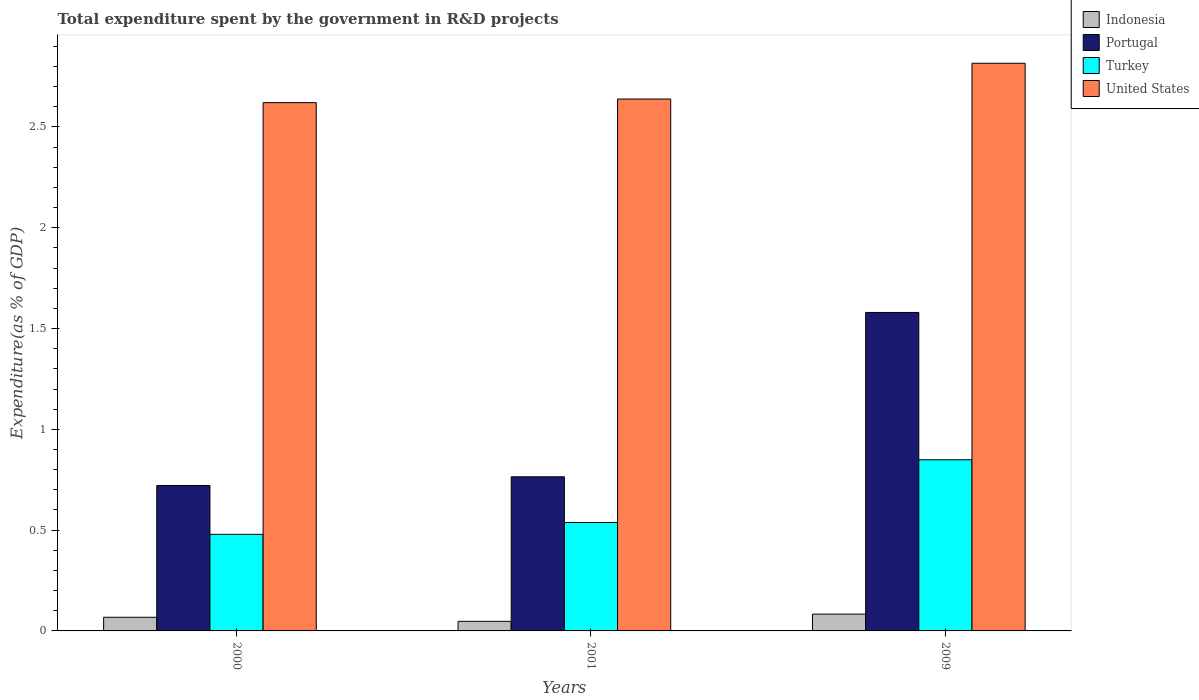How many different coloured bars are there?
Ensure brevity in your answer.  4. Are the number of bars per tick equal to the number of legend labels?
Your answer should be very brief. Yes. How many bars are there on the 2nd tick from the left?
Your answer should be compact. 4. How many bars are there on the 3rd tick from the right?
Your answer should be very brief. 4. What is the label of the 3rd group of bars from the left?
Keep it short and to the point. 2009. In how many cases, is the number of bars for a given year not equal to the number of legend labels?
Provide a short and direct response. 0. What is the total expenditure spent by the government in R&D projects in Turkey in 2000?
Provide a succinct answer. 0.48. Across all years, what is the maximum total expenditure spent by the government in R&D projects in United States?
Keep it short and to the point. 2.82. Across all years, what is the minimum total expenditure spent by the government in R&D projects in Indonesia?
Ensure brevity in your answer.  0.05. In which year was the total expenditure spent by the government in R&D projects in Indonesia maximum?
Offer a terse response. 2009. In which year was the total expenditure spent by the government in R&D projects in Portugal minimum?
Ensure brevity in your answer.  2000. What is the total total expenditure spent by the government in R&D projects in Turkey in the graph?
Give a very brief answer. 1.87. What is the difference between the total expenditure spent by the government in R&D projects in Indonesia in 2001 and that in 2009?
Offer a terse response. -0.04. What is the difference between the total expenditure spent by the government in R&D projects in Indonesia in 2000 and the total expenditure spent by the government in R&D projects in Portugal in 2009?
Your response must be concise. -1.51. What is the average total expenditure spent by the government in R&D projects in Indonesia per year?
Your response must be concise. 0.07. In the year 2009, what is the difference between the total expenditure spent by the government in R&D projects in Portugal and total expenditure spent by the government in R&D projects in Turkey?
Your answer should be compact. 0.73. In how many years, is the total expenditure spent by the government in R&D projects in Indonesia greater than 0.4 %?
Give a very brief answer. 0. What is the ratio of the total expenditure spent by the government in R&D projects in Turkey in 2000 to that in 2009?
Ensure brevity in your answer.  0.56. Is the total expenditure spent by the government in R&D projects in Indonesia in 2000 less than that in 2009?
Give a very brief answer. Yes. What is the difference between the highest and the second highest total expenditure spent by the government in R&D projects in United States?
Your answer should be very brief. 0.18. What is the difference between the highest and the lowest total expenditure spent by the government in R&D projects in United States?
Ensure brevity in your answer.  0.2. In how many years, is the total expenditure spent by the government in R&D projects in Indonesia greater than the average total expenditure spent by the government in R&D projects in Indonesia taken over all years?
Ensure brevity in your answer.  2. Is it the case that in every year, the sum of the total expenditure spent by the government in R&D projects in Indonesia and total expenditure spent by the government in R&D projects in Portugal is greater than the total expenditure spent by the government in R&D projects in Turkey?
Keep it short and to the point. Yes. Are all the bars in the graph horizontal?
Ensure brevity in your answer.  No. How many years are there in the graph?
Keep it short and to the point. 3. What is the difference between two consecutive major ticks on the Y-axis?
Give a very brief answer. 0.5. Does the graph contain any zero values?
Offer a terse response. No. Does the graph contain grids?
Your answer should be compact. No. Where does the legend appear in the graph?
Your answer should be compact. Top right. What is the title of the graph?
Make the answer very short. Total expenditure spent by the government in R&D projects. Does "Czech Republic" appear as one of the legend labels in the graph?
Provide a succinct answer. No. What is the label or title of the Y-axis?
Give a very brief answer. Expenditure(as % of GDP). What is the Expenditure(as % of GDP) of Indonesia in 2000?
Offer a terse response. 0.07. What is the Expenditure(as % of GDP) in Portugal in 2000?
Make the answer very short. 0.72. What is the Expenditure(as % of GDP) in Turkey in 2000?
Your answer should be compact. 0.48. What is the Expenditure(as % of GDP) of United States in 2000?
Offer a terse response. 2.62. What is the Expenditure(as % of GDP) of Indonesia in 2001?
Offer a very short reply. 0.05. What is the Expenditure(as % of GDP) in Portugal in 2001?
Ensure brevity in your answer.  0.76. What is the Expenditure(as % of GDP) of Turkey in 2001?
Offer a very short reply. 0.54. What is the Expenditure(as % of GDP) of United States in 2001?
Keep it short and to the point. 2.64. What is the Expenditure(as % of GDP) of Indonesia in 2009?
Your answer should be compact. 0.08. What is the Expenditure(as % of GDP) of Portugal in 2009?
Keep it short and to the point. 1.58. What is the Expenditure(as % of GDP) of Turkey in 2009?
Ensure brevity in your answer.  0.85. What is the Expenditure(as % of GDP) of United States in 2009?
Provide a short and direct response. 2.82. Across all years, what is the maximum Expenditure(as % of GDP) of Indonesia?
Ensure brevity in your answer.  0.08. Across all years, what is the maximum Expenditure(as % of GDP) in Portugal?
Your answer should be compact. 1.58. Across all years, what is the maximum Expenditure(as % of GDP) in Turkey?
Offer a terse response. 0.85. Across all years, what is the maximum Expenditure(as % of GDP) in United States?
Your answer should be compact. 2.82. Across all years, what is the minimum Expenditure(as % of GDP) of Indonesia?
Your answer should be compact. 0.05. Across all years, what is the minimum Expenditure(as % of GDP) in Portugal?
Make the answer very short. 0.72. Across all years, what is the minimum Expenditure(as % of GDP) of Turkey?
Provide a short and direct response. 0.48. Across all years, what is the minimum Expenditure(as % of GDP) in United States?
Ensure brevity in your answer.  2.62. What is the total Expenditure(as % of GDP) of Indonesia in the graph?
Offer a terse response. 0.2. What is the total Expenditure(as % of GDP) of Portugal in the graph?
Offer a terse response. 3.07. What is the total Expenditure(as % of GDP) of Turkey in the graph?
Keep it short and to the point. 1.87. What is the total Expenditure(as % of GDP) of United States in the graph?
Make the answer very short. 8.07. What is the difference between the Expenditure(as % of GDP) of Indonesia in 2000 and that in 2001?
Provide a succinct answer. 0.02. What is the difference between the Expenditure(as % of GDP) of Portugal in 2000 and that in 2001?
Offer a terse response. -0.04. What is the difference between the Expenditure(as % of GDP) of Turkey in 2000 and that in 2001?
Give a very brief answer. -0.06. What is the difference between the Expenditure(as % of GDP) in United States in 2000 and that in 2001?
Provide a succinct answer. -0.02. What is the difference between the Expenditure(as % of GDP) of Indonesia in 2000 and that in 2009?
Your response must be concise. -0.02. What is the difference between the Expenditure(as % of GDP) of Portugal in 2000 and that in 2009?
Provide a succinct answer. -0.86. What is the difference between the Expenditure(as % of GDP) of Turkey in 2000 and that in 2009?
Your answer should be very brief. -0.37. What is the difference between the Expenditure(as % of GDP) in United States in 2000 and that in 2009?
Your response must be concise. -0.2. What is the difference between the Expenditure(as % of GDP) of Indonesia in 2001 and that in 2009?
Your answer should be compact. -0.04. What is the difference between the Expenditure(as % of GDP) of Portugal in 2001 and that in 2009?
Offer a terse response. -0.82. What is the difference between the Expenditure(as % of GDP) in Turkey in 2001 and that in 2009?
Provide a short and direct response. -0.31. What is the difference between the Expenditure(as % of GDP) in United States in 2001 and that in 2009?
Your answer should be very brief. -0.18. What is the difference between the Expenditure(as % of GDP) in Indonesia in 2000 and the Expenditure(as % of GDP) in Portugal in 2001?
Your answer should be compact. -0.7. What is the difference between the Expenditure(as % of GDP) of Indonesia in 2000 and the Expenditure(as % of GDP) of Turkey in 2001?
Your response must be concise. -0.47. What is the difference between the Expenditure(as % of GDP) in Indonesia in 2000 and the Expenditure(as % of GDP) in United States in 2001?
Provide a short and direct response. -2.57. What is the difference between the Expenditure(as % of GDP) in Portugal in 2000 and the Expenditure(as % of GDP) in Turkey in 2001?
Provide a succinct answer. 0.18. What is the difference between the Expenditure(as % of GDP) in Portugal in 2000 and the Expenditure(as % of GDP) in United States in 2001?
Your response must be concise. -1.92. What is the difference between the Expenditure(as % of GDP) of Turkey in 2000 and the Expenditure(as % of GDP) of United States in 2001?
Provide a short and direct response. -2.16. What is the difference between the Expenditure(as % of GDP) of Indonesia in 2000 and the Expenditure(as % of GDP) of Portugal in 2009?
Your answer should be compact. -1.51. What is the difference between the Expenditure(as % of GDP) in Indonesia in 2000 and the Expenditure(as % of GDP) in Turkey in 2009?
Your response must be concise. -0.78. What is the difference between the Expenditure(as % of GDP) in Indonesia in 2000 and the Expenditure(as % of GDP) in United States in 2009?
Your response must be concise. -2.75. What is the difference between the Expenditure(as % of GDP) of Portugal in 2000 and the Expenditure(as % of GDP) of Turkey in 2009?
Make the answer very short. -0.13. What is the difference between the Expenditure(as % of GDP) in Portugal in 2000 and the Expenditure(as % of GDP) in United States in 2009?
Ensure brevity in your answer.  -2.09. What is the difference between the Expenditure(as % of GDP) in Turkey in 2000 and the Expenditure(as % of GDP) in United States in 2009?
Your answer should be compact. -2.34. What is the difference between the Expenditure(as % of GDP) of Indonesia in 2001 and the Expenditure(as % of GDP) of Portugal in 2009?
Offer a very short reply. -1.53. What is the difference between the Expenditure(as % of GDP) of Indonesia in 2001 and the Expenditure(as % of GDP) of Turkey in 2009?
Keep it short and to the point. -0.8. What is the difference between the Expenditure(as % of GDP) of Indonesia in 2001 and the Expenditure(as % of GDP) of United States in 2009?
Your answer should be compact. -2.77. What is the difference between the Expenditure(as % of GDP) in Portugal in 2001 and the Expenditure(as % of GDP) in Turkey in 2009?
Your answer should be compact. -0.08. What is the difference between the Expenditure(as % of GDP) of Portugal in 2001 and the Expenditure(as % of GDP) of United States in 2009?
Provide a succinct answer. -2.05. What is the difference between the Expenditure(as % of GDP) of Turkey in 2001 and the Expenditure(as % of GDP) of United States in 2009?
Offer a very short reply. -2.28. What is the average Expenditure(as % of GDP) in Indonesia per year?
Offer a terse response. 0.07. What is the average Expenditure(as % of GDP) of Portugal per year?
Make the answer very short. 1.02. What is the average Expenditure(as % of GDP) in Turkey per year?
Your answer should be compact. 0.62. What is the average Expenditure(as % of GDP) in United States per year?
Provide a short and direct response. 2.69. In the year 2000, what is the difference between the Expenditure(as % of GDP) of Indonesia and Expenditure(as % of GDP) of Portugal?
Keep it short and to the point. -0.65. In the year 2000, what is the difference between the Expenditure(as % of GDP) in Indonesia and Expenditure(as % of GDP) in Turkey?
Provide a succinct answer. -0.41. In the year 2000, what is the difference between the Expenditure(as % of GDP) in Indonesia and Expenditure(as % of GDP) in United States?
Offer a terse response. -2.55. In the year 2000, what is the difference between the Expenditure(as % of GDP) in Portugal and Expenditure(as % of GDP) in Turkey?
Provide a short and direct response. 0.24. In the year 2000, what is the difference between the Expenditure(as % of GDP) in Portugal and Expenditure(as % of GDP) in United States?
Make the answer very short. -1.9. In the year 2000, what is the difference between the Expenditure(as % of GDP) of Turkey and Expenditure(as % of GDP) of United States?
Give a very brief answer. -2.14. In the year 2001, what is the difference between the Expenditure(as % of GDP) in Indonesia and Expenditure(as % of GDP) in Portugal?
Make the answer very short. -0.72. In the year 2001, what is the difference between the Expenditure(as % of GDP) of Indonesia and Expenditure(as % of GDP) of Turkey?
Ensure brevity in your answer.  -0.49. In the year 2001, what is the difference between the Expenditure(as % of GDP) in Indonesia and Expenditure(as % of GDP) in United States?
Make the answer very short. -2.59. In the year 2001, what is the difference between the Expenditure(as % of GDP) of Portugal and Expenditure(as % of GDP) of Turkey?
Ensure brevity in your answer.  0.23. In the year 2001, what is the difference between the Expenditure(as % of GDP) of Portugal and Expenditure(as % of GDP) of United States?
Give a very brief answer. -1.87. In the year 2001, what is the difference between the Expenditure(as % of GDP) in Turkey and Expenditure(as % of GDP) in United States?
Make the answer very short. -2.1. In the year 2009, what is the difference between the Expenditure(as % of GDP) of Indonesia and Expenditure(as % of GDP) of Portugal?
Provide a succinct answer. -1.5. In the year 2009, what is the difference between the Expenditure(as % of GDP) of Indonesia and Expenditure(as % of GDP) of Turkey?
Your response must be concise. -0.77. In the year 2009, what is the difference between the Expenditure(as % of GDP) in Indonesia and Expenditure(as % of GDP) in United States?
Keep it short and to the point. -2.73. In the year 2009, what is the difference between the Expenditure(as % of GDP) of Portugal and Expenditure(as % of GDP) of Turkey?
Provide a short and direct response. 0.73. In the year 2009, what is the difference between the Expenditure(as % of GDP) of Portugal and Expenditure(as % of GDP) of United States?
Make the answer very short. -1.24. In the year 2009, what is the difference between the Expenditure(as % of GDP) of Turkey and Expenditure(as % of GDP) of United States?
Your answer should be very brief. -1.97. What is the ratio of the Expenditure(as % of GDP) in Indonesia in 2000 to that in 2001?
Make the answer very short. 1.42. What is the ratio of the Expenditure(as % of GDP) of Portugal in 2000 to that in 2001?
Provide a succinct answer. 0.94. What is the ratio of the Expenditure(as % of GDP) in Turkey in 2000 to that in 2001?
Offer a very short reply. 0.89. What is the ratio of the Expenditure(as % of GDP) of United States in 2000 to that in 2001?
Make the answer very short. 0.99. What is the ratio of the Expenditure(as % of GDP) in Indonesia in 2000 to that in 2009?
Keep it short and to the point. 0.81. What is the ratio of the Expenditure(as % of GDP) of Portugal in 2000 to that in 2009?
Your answer should be very brief. 0.46. What is the ratio of the Expenditure(as % of GDP) in Turkey in 2000 to that in 2009?
Offer a very short reply. 0.56. What is the ratio of the Expenditure(as % of GDP) in United States in 2000 to that in 2009?
Ensure brevity in your answer.  0.93. What is the ratio of the Expenditure(as % of GDP) of Indonesia in 2001 to that in 2009?
Offer a terse response. 0.57. What is the ratio of the Expenditure(as % of GDP) of Portugal in 2001 to that in 2009?
Ensure brevity in your answer.  0.48. What is the ratio of the Expenditure(as % of GDP) in Turkey in 2001 to that in 2009?
Offer a very short reply. 0.63. What is the ratio of the Expenditure(as % of GDP) in United States in 2001 to that in 2009?
Your answer should be compact. 0.94. What is the difference between the highest and the second highest Expenditure(as % of GDP) of Indonesia?
Give a very brief answer. 0.02. What is the difference between the highest and the second highest Expenditure(as % of GDP) of Portugal?
Keep it short and to the point. 0.82. What is the difference between the highest and the second highest Expenditure(as % of GDP) of Turkey?
Your response must be concise. 0.31. What is the difference between the highest and the second highest Expenditure(as % of GDP) in United States?
Make the answer very short. 0.18. What is the difference between the highest and the lowest Expenditure(as % of GDP) of Indonesia?
Provide a short and direct response. 0.04. What is the difference between the highest and the lowest Expenditure(as % of GDP) of Portugal?
Keep it short and to the point. 0.86. What is the difference between the highest and the lowest Expenditure(as % of GDP) of Turkey?
Provide a short and direct response. 0.37. What is the difference between the highest and the lowest Expenditure(as % of GDP) of United States?
Offer a very short reply. 0.2. 